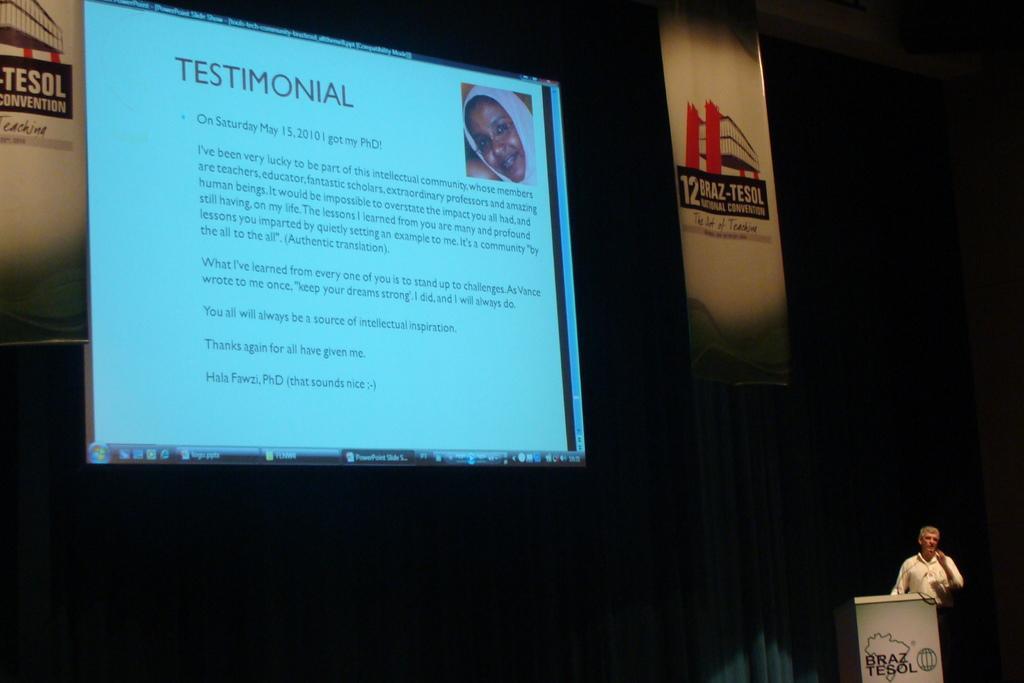Describe this image in one or two sentences. In this picture we can see a screen,on this screen we can see some text,here we can see a person,podium,mic. 